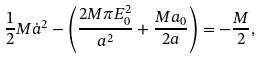Convert formula to latex. <formula><loc_0><loc_0><loc_500><loc_500>\frac { 1 } { 2 } M \dot { a } ^ { 2 } - \left ( \frac { 2 M \pi E _ { 0 } ^ { 2 } } { a ^ { 2 } } + \frac { M a _ { 0 } } { 2 a } \right ) = - \frac { M } { 2 } ,</formula> 